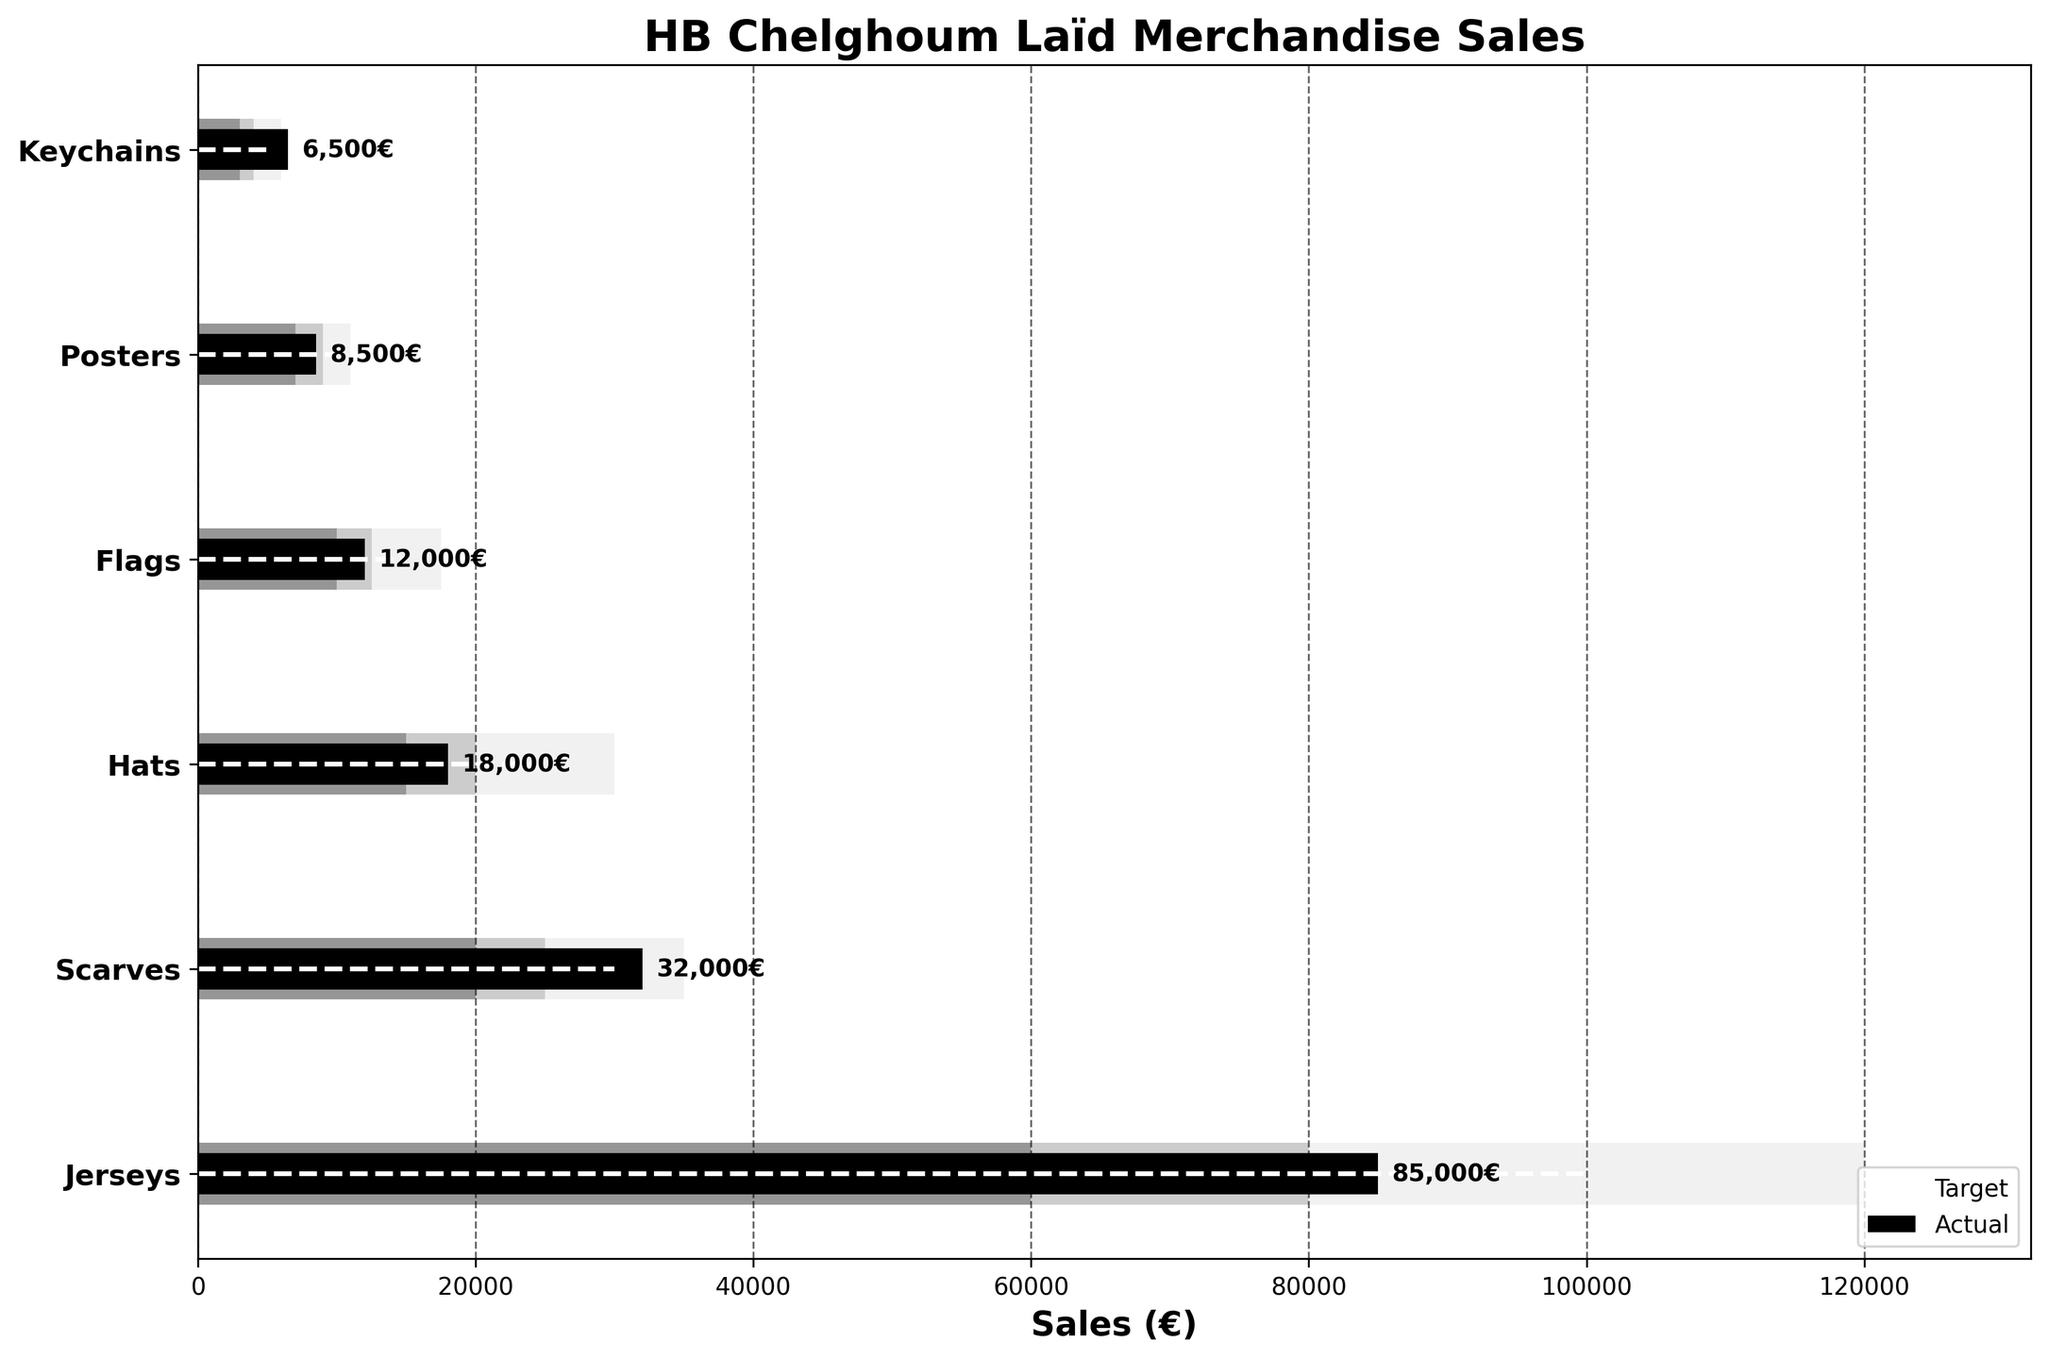What is the title of the bullet chart? The title of the chart is usually displayed at the top of the figure. It is written in bold and generally provides an overview of what the chart is about. In this case, the title is "HB Chelghoum Laïd Merchandise Sales".
Answer: HB Chelghoum Laïd Merchandise Sales How many merchandise categories are represented in the bullet chart? The categories are listed on the y-axis. By counting the entries, we find there are six categories: Jerseys, Scarves, Hats, Flags, Posters, and Keychains.
Answer: Six Which category exceeded its target the most? To find the category that exceeded its target by the most, we look for the greatest positive difference between the actual sales bar and the target line. Scarves exceeded its target by 2,000€.
Answer: Scarves Which category had the lowest actual sales? To determine this, examine the length of the bars representing actual sales. The shortest bar represents Keychains with 6,500€.
Answer: Keychains Are there any categories where actual sales were less than the low end of the Range1? Range1 represents the lowest acceptable sales range. We need to find any category where the actual sales bar is shorter than the Range1 bar. Hats is one such category.
Answer: Hats How much more would Hats need to reach its target? Hats has actual sales of 18,000€, and its target is 25,000€. The difference (25,000 - 18,000) is the amount needed.
Answer: 7,000€ Which category's actual sales most closely match its target? Examine how close the end of the actual sales bar is to the target line. Jerseys have 85,000€ in actual sales and a target of 100,000€, which is closest compared to other categories.
Answer: Jerseys In which categories are actual sales within Range2? Range2 represents a mid-range of acceptable sales. Check if the actual sales bar fits within this range for each category. Scarves and Flags have actual sales within Range2.
Answer: Scarves and Flags Compare the actual sales of Jerseys and Hats. Which one performed better and by how much? Compare the actual sales bar lengths of the two categories. Jerseys have 85,000€ in actual sales, while Hats have 18,000€. The difference is 85,000 - 18,000.
Answer: Jerseys by 67,000€ Which category is closest to reaching Range3 values for actual sales? The Range3 bars represent the highest acceptable sales range. See which category's actual sales bar extends closest to this range. Jerseys' actual sales are closest to Range3.
Answer: Jerseys 